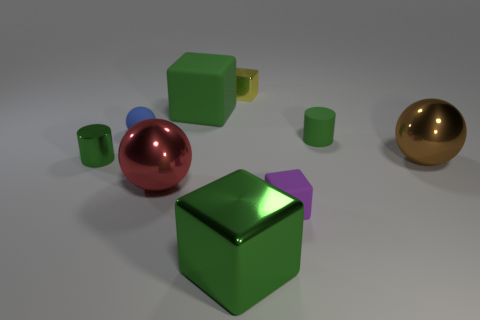How many green cubes must be subtracted to get 1 green cubes? 1 Subtract all rubber spheres. How many spheres are left? 2 Add 1 green shiny objects. How many objects exist? 10 Subtract all brown balls. How many balls are left? 2 Subtract 2 cylinders. How many cylinders are left? 0 Subtract all green cylinders. How many blue blocks are left? 0 Subtract all small yellow matte things. Subtract all large rubber things. How many objects are left? 8 Add 9 purple matte things. How many purple matte things are left? 10 Add 2 large cyan things. How many large cyan things exist? 2 Subtract 0 cyan cylinders. How many objects are left? 9 